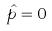<formula> <loc_0><loc_0><loc_500><loc_500>\hat { p } = 0</formula> 